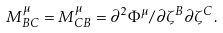Convert formula to latex. <formula><loc_0><loc_0><loc_500><loc_500>M ^ { \mu } _ { B C } = M ^ { \mu } _ { C B } = \partial ^ { 2 } \Phi ^ { \mu } / \partial \zeta ^ { B } \partial \zeta ^ { C } .</formula> 